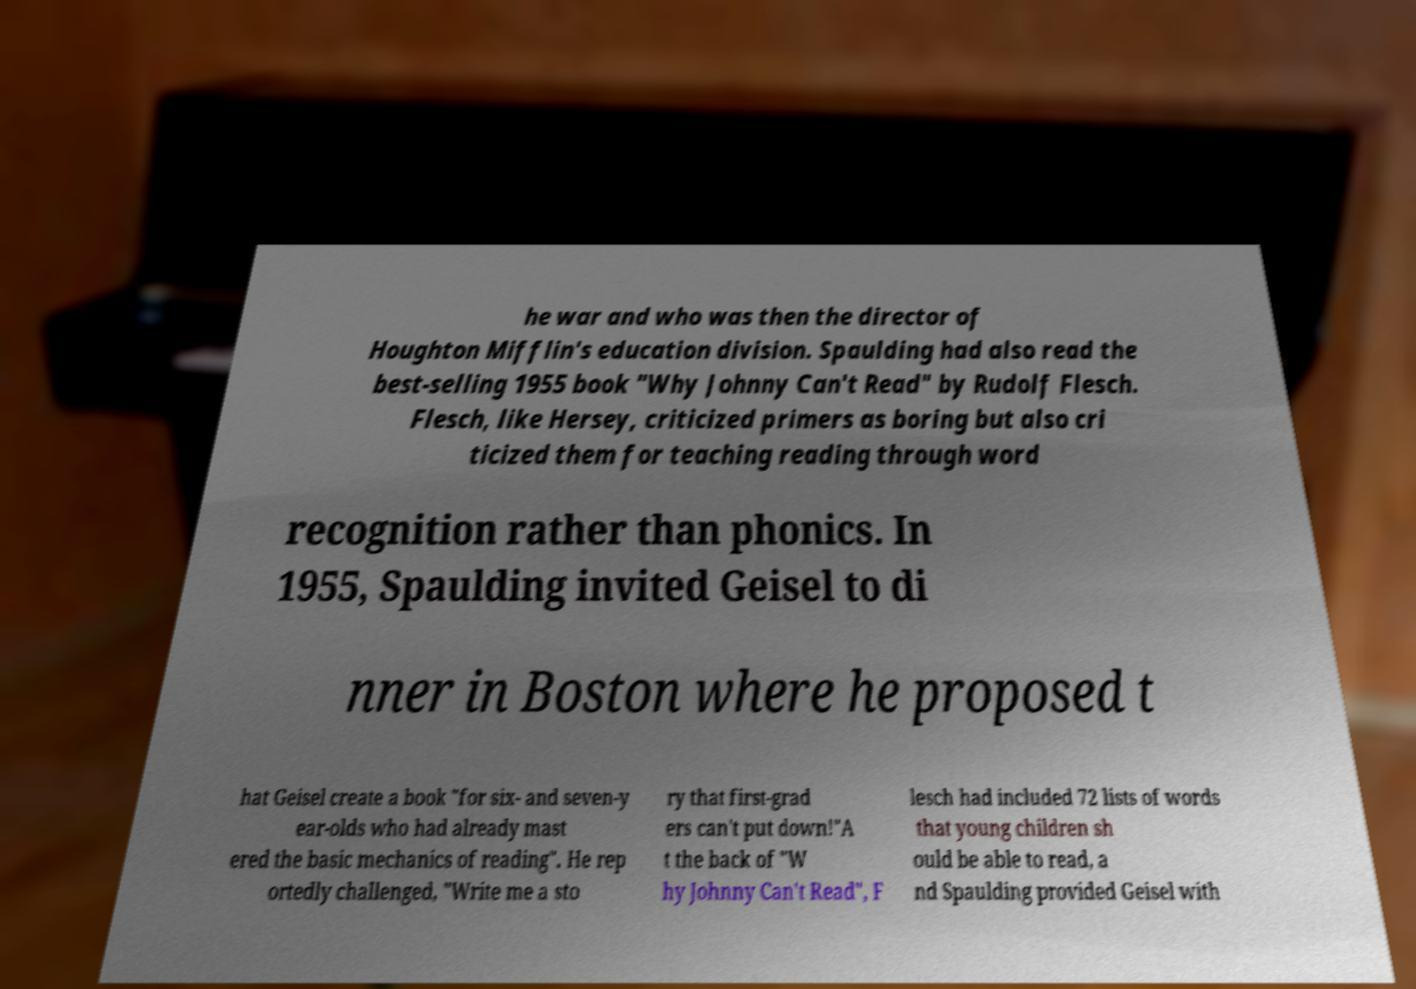Can you accurately transcribe the text from the provided image for me? he war and who was then the director of Houghton Mifflin's education division. Spaulding had also read the best-selling 1955 book "Why Johnny Can't Read" by Rudolf Flesch. Flesch, like Hersey, criticized primers as boring but also cri ticized them for teaching reading through word recognition rather than phonics. In 1955, Spaulding invited Geisel to di nner in Boston where he proposed t hat Geisel create a book "for six- and seven-y ear-olds who had already mast ered the basic mechanics of reading". He rep ortedly challenged, "Write me a sto ry that first-grad ers can't put down!"A t the back of "W hy Johnny Can't Read", F lesch had included 72 lists of words that young children sh ould be able to read, a nd Spaulding provided Geisel with 